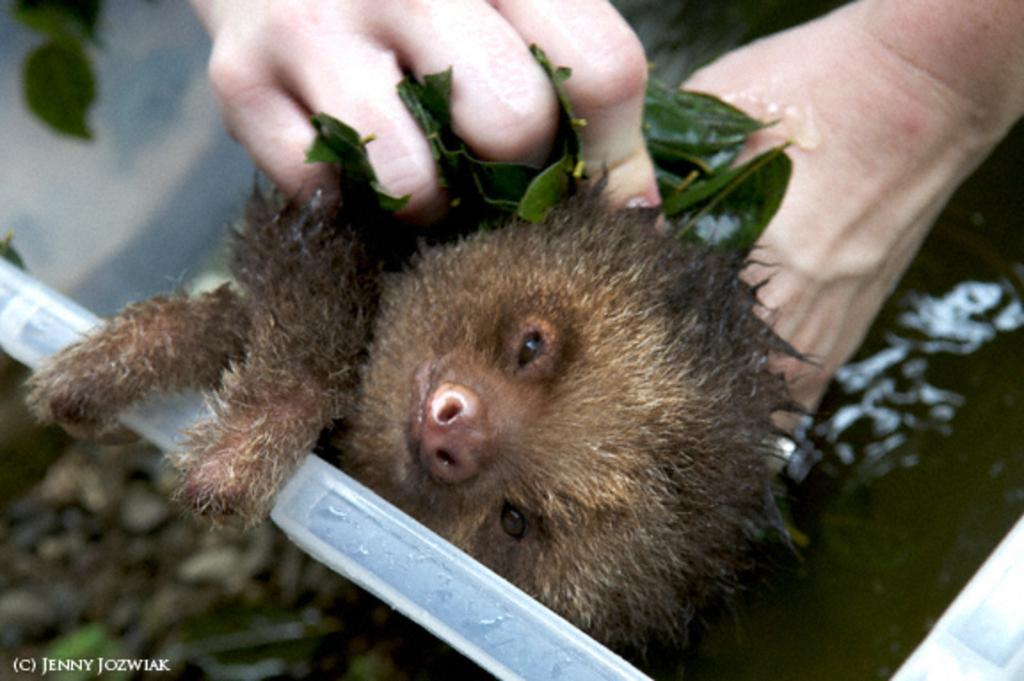What type of living creature is present in the image? There is an animal in the image. How is the animal being held or interacted with? A person is holding the animal's body. Where is the shelf located in the image? There is no shelf present in the image. What type of needle is being used by the animal in the image? There is no needle present in the image, and the animal is not performing any action that would require a needle. 